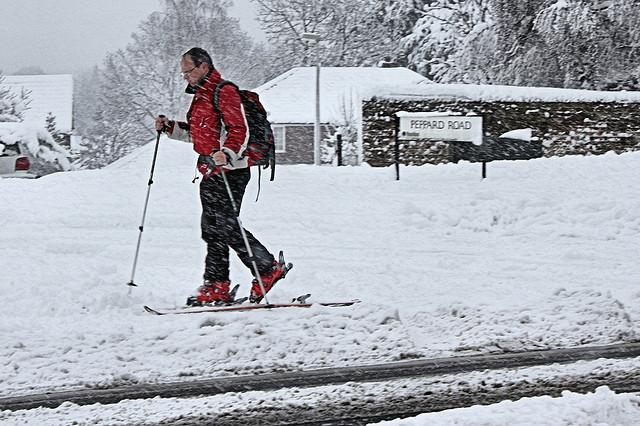What caused the lines in the snow?

Choices:
A) car wheels
B) skis
C) animal
D) shovel car wheels 